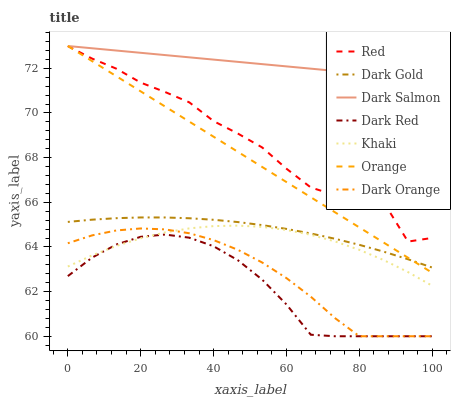Does Dark Red have the minimum area under the curve?
Answer yes or no. Yes. Does Dark Salmon have the maximum area under the curve?
Answer yes or no. Yes. Does Khaki have the minimum area under the curve?
Answer yes or no. No. Does Khaki have the maximum area under the curve?
Answer yes or no. No. Is Dark Salmon the smoothest?
Answer yes or no. Yes. Is Red the roughest?
Answer yes or no. Yes. Is Khaki the smoothest?
Answer yes or no. No. Is Khaki the roughest?
Answer yes or no. No. Does Dark Orange have the lowest value?
Answer yes or no. Yes. Does Khaki have the lowest value?
Answer yes or no. No. Does Orange have the highest value?
Answer yes or no. Yes. Does Khaki have the highest value?
Answer yes or no. No. Is Dark Gold less than Dark Salmon?
Answer yes or no. Yes. Is Dark Gold greater than Khaki?
Answer yes or no. Yes. Does Dark Orange intersect Khaki?
Answer yes or no. Yes. Is Dark Orange less than Khaki?
Answer yes or no. No. Is Dark Orange greater than Khaki?
Answer yes or no. No. Does Dark Gold intersect Dark Salmon?
Answer yes or no. No. 